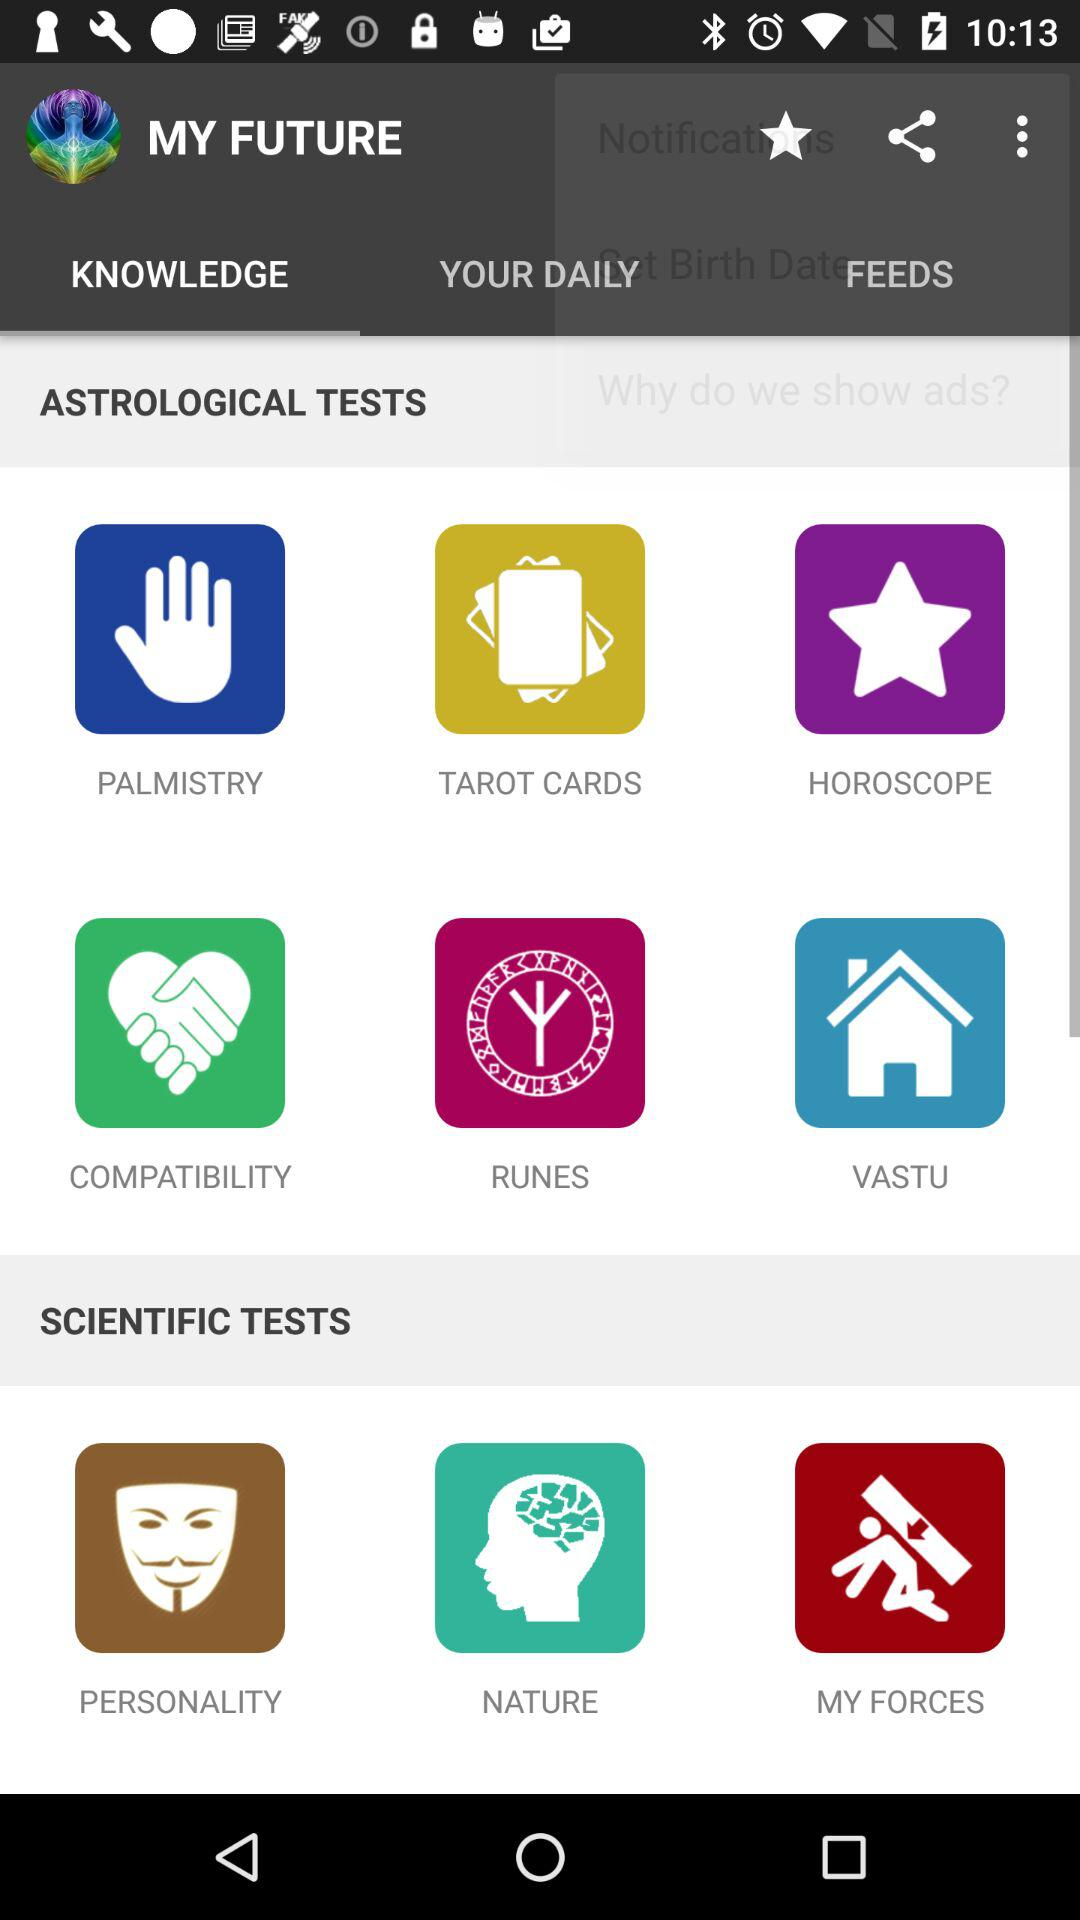How many more astrological tests are there than scientific tests?
Answer the question using a single word or phrase. 3 